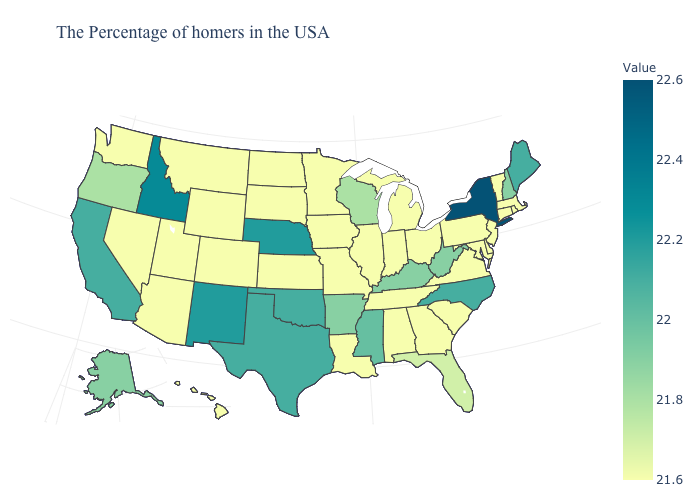Among the states that border Oklahoma , does Missouri have the highest value?
Keep it brief. No. Does Wisconsin have the lowest value in the MidWest?
Be succinct. No. Among the states that border Iowa , does Nebraska have the highest value?
Short answer required. Yes. Is the legend a continuous bar?
Keep it brief. Yes. Among the states that border Indiana , does Illinois have the highest value?
Answer briefly. No. Does North Carolina have the lowest value in the South?
Quick response, please. No. 